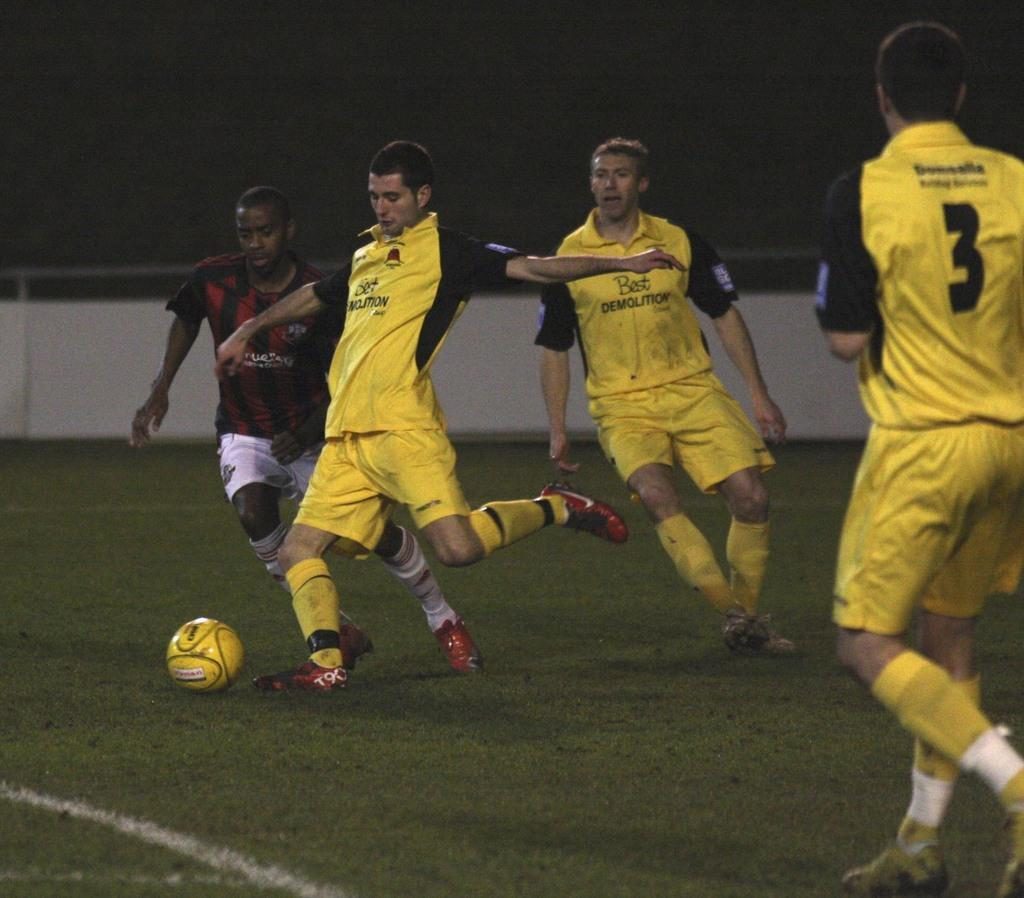<image>
Present a compact description of the photo's key features. A player wearing a Best Demolition uniform kicks a soccer ball. 